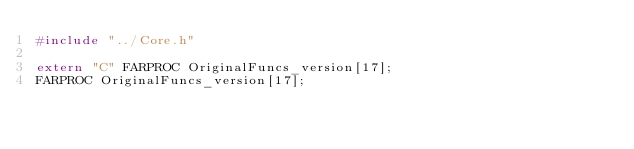<code> <loc_0><loc_0><loc_500><loc_500><_C++_>#include "../Core.h"

extern "C" FARPROC OriginalFuncs_version[17];
FARPROC OriginalFuncs_version[17];</code> 